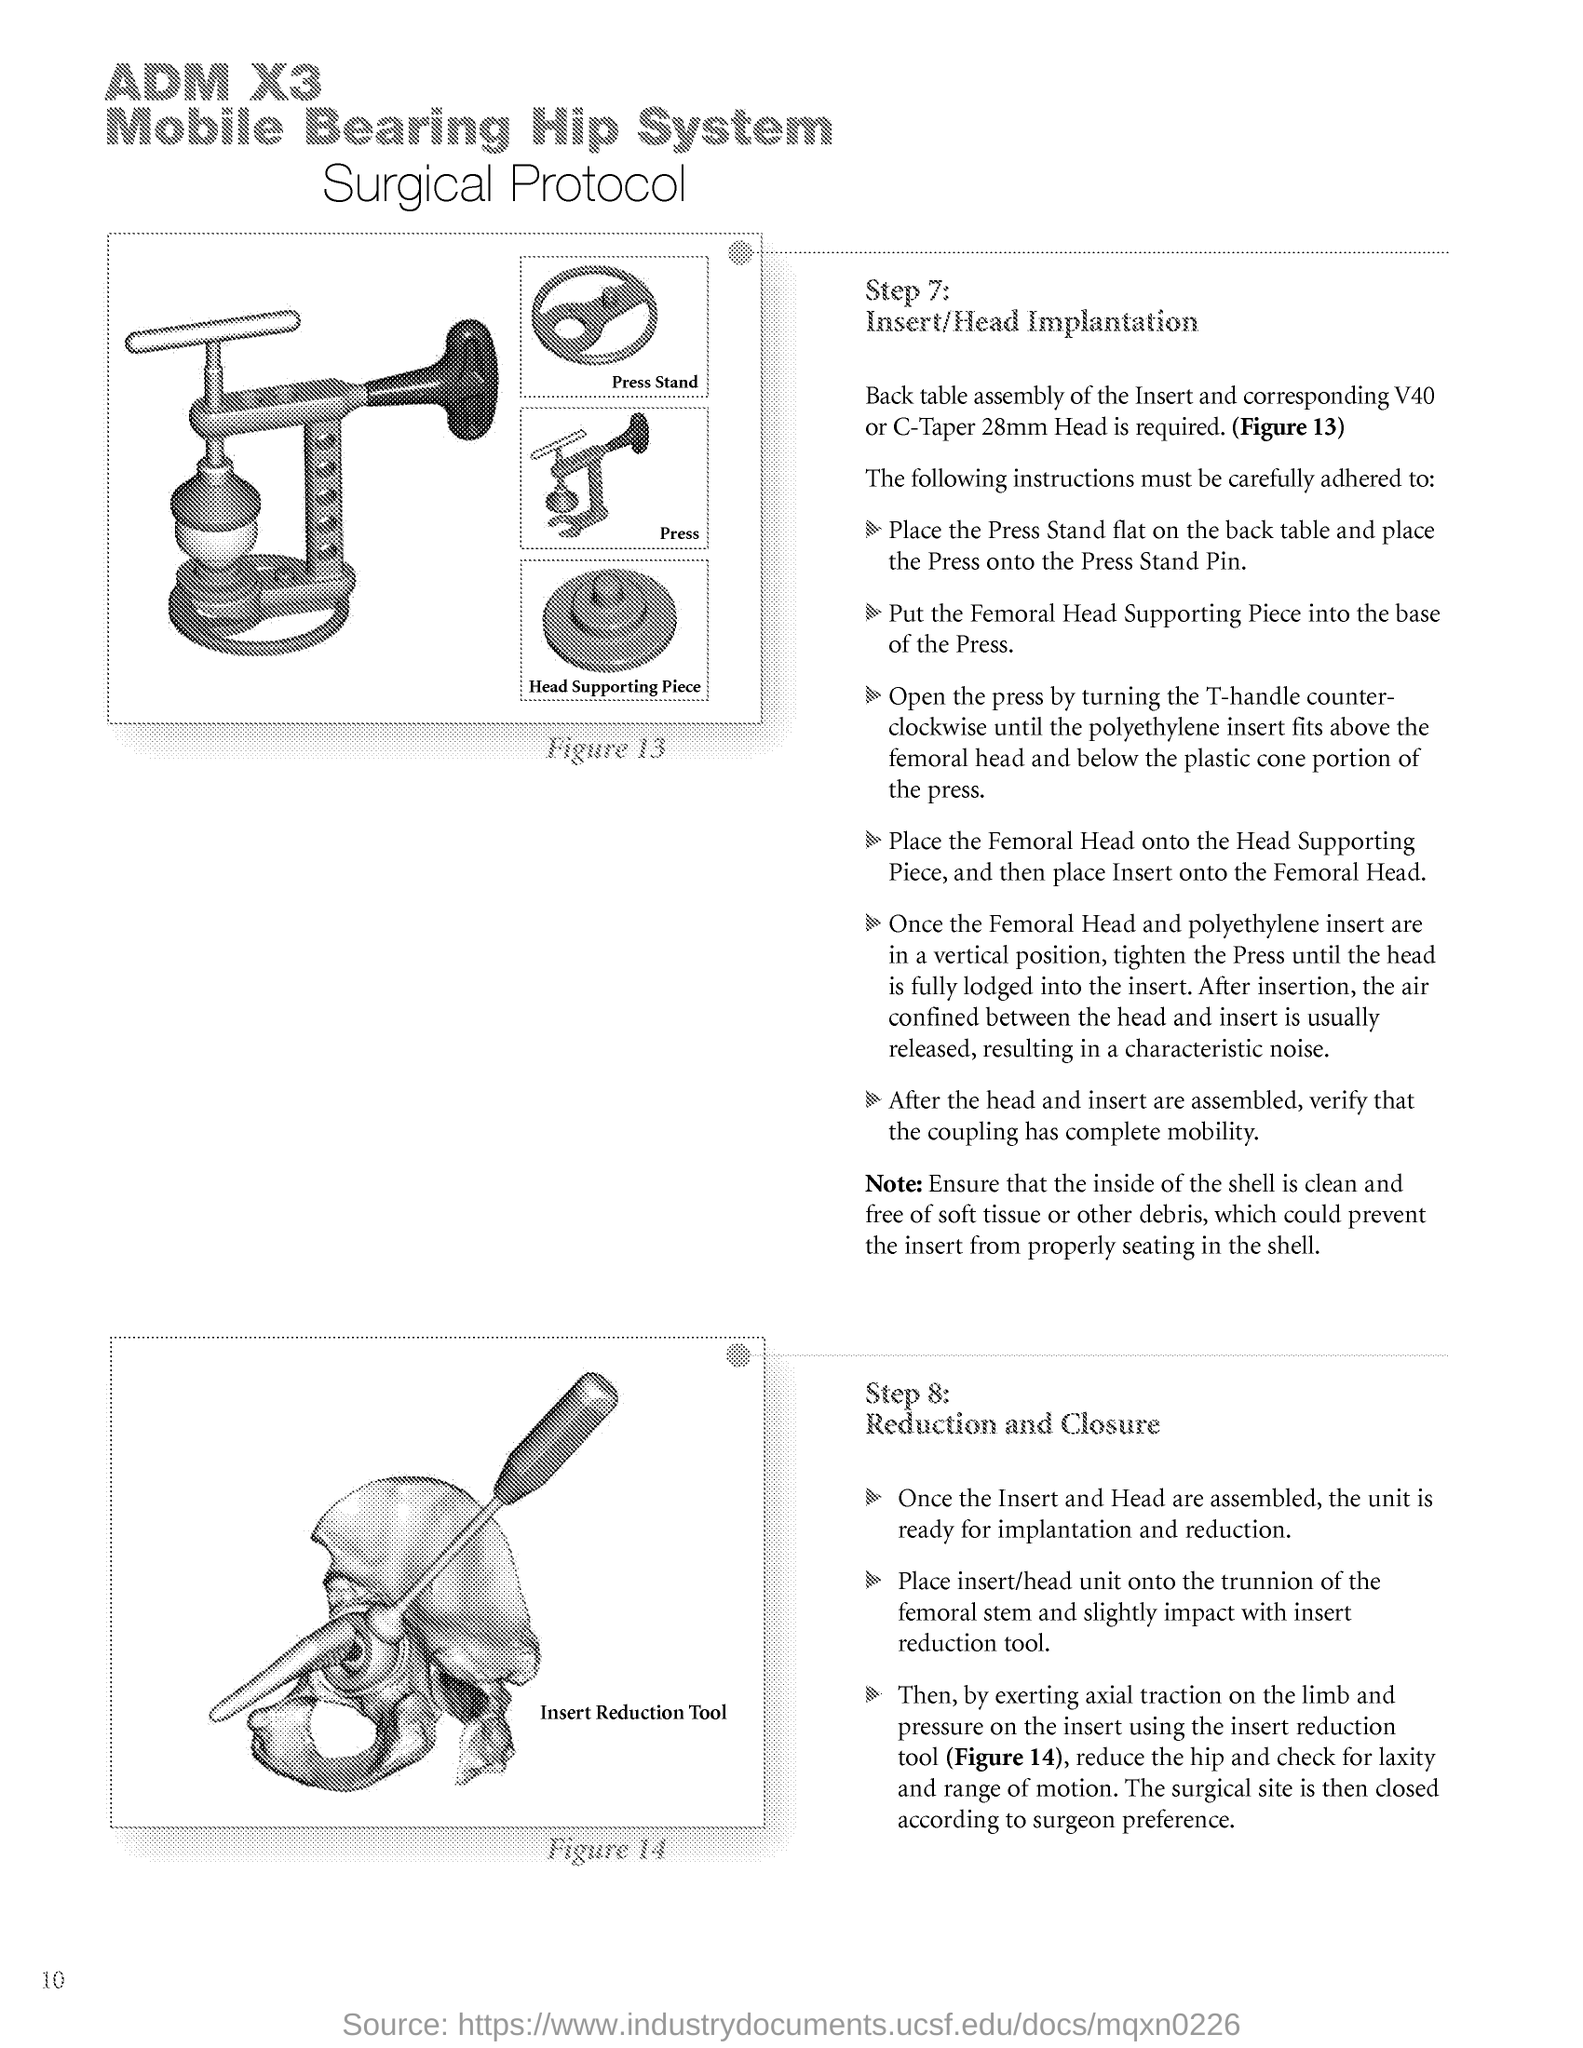What is Step Number 7?
Offer a very short reply. Insert/Head Implantation. What is Step Number 8?
Provide a succinct answer. Reduction and Closure. What is the Page Number?
Your answer should be very brief. 10. 